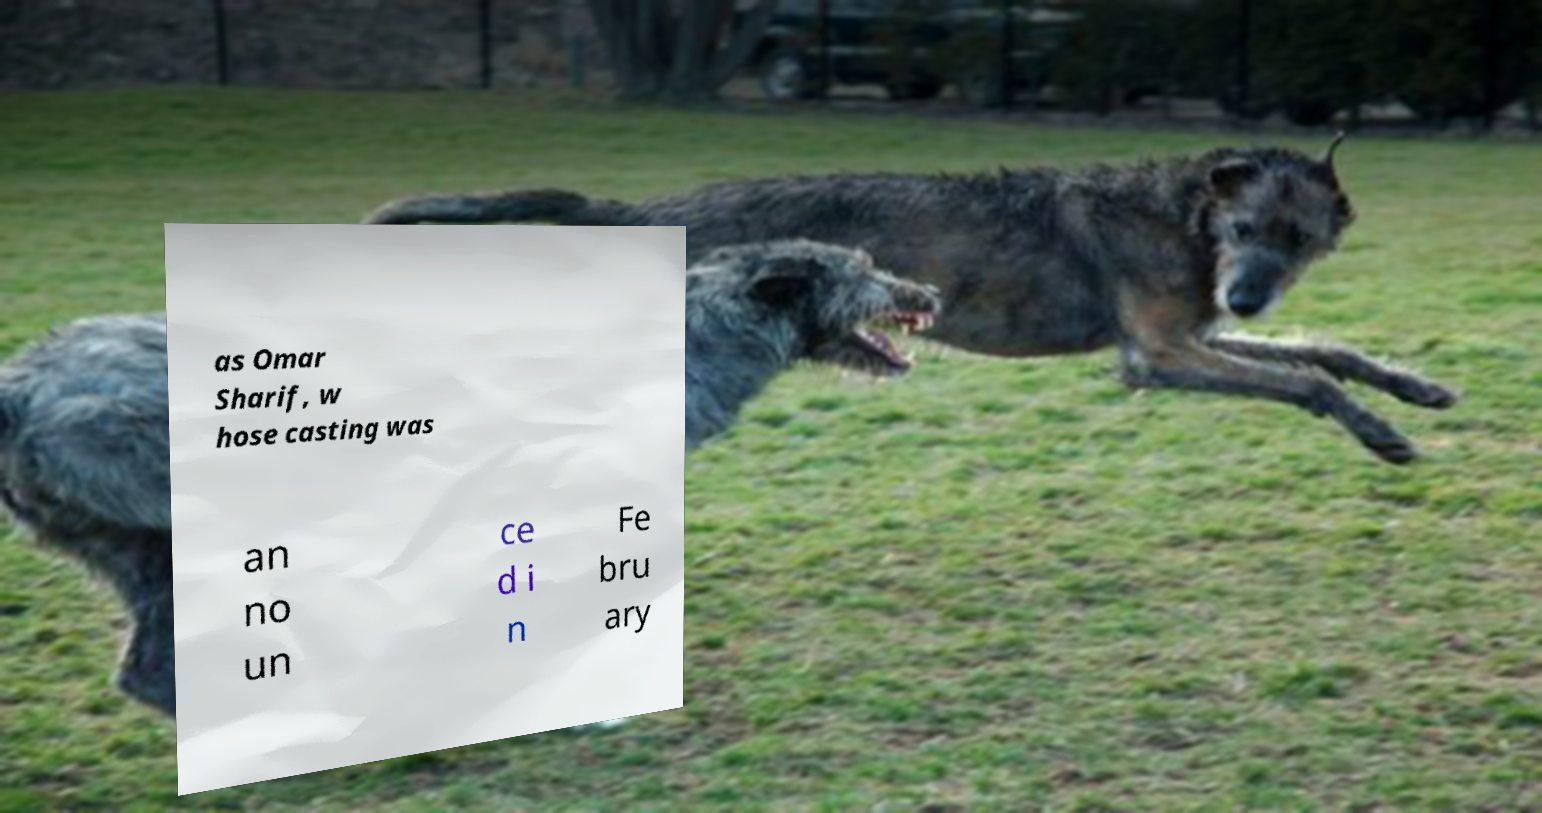Could you assist in decoding the text presented in this image and type it out clearly? as Omar Sharif, w hose casting was an no un ce d i n Fe bru ary 